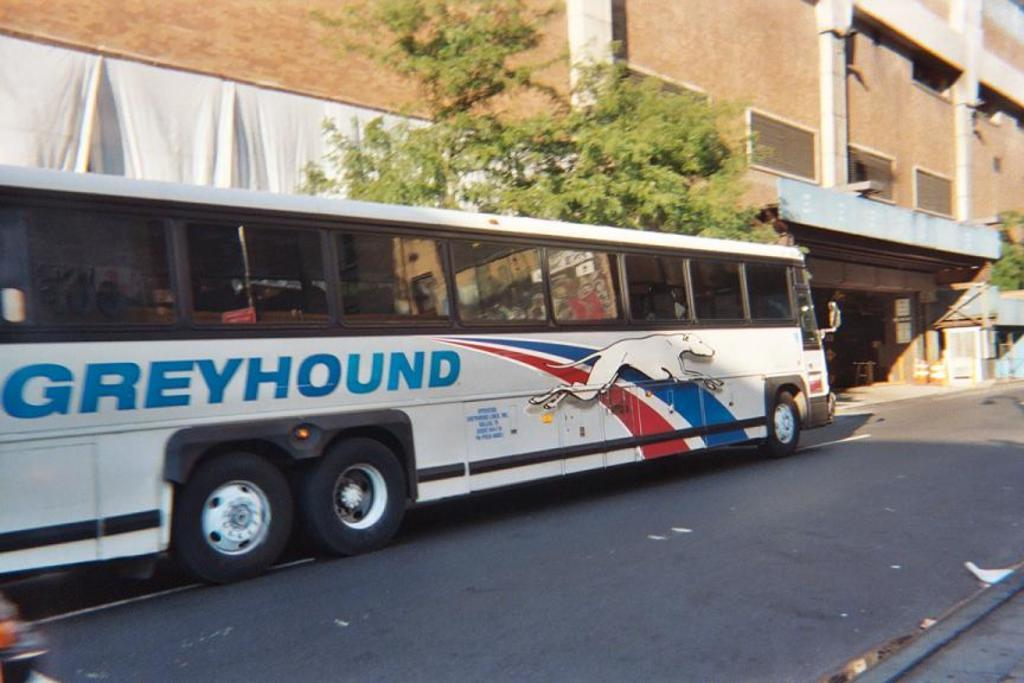What is the main subject of the image? There is a bus in the image. Where is the bus located? The bus is on the road. What can be seen on the bus? There is writing on the bus. What can be seen in the background of the image? There are trees, a building, and other objects visible in the background of the image. What type of pipe can be seen being used by the bus driver in the image? There is no pipe visible in the image, nor is there any indication that the bus driver is using one. 